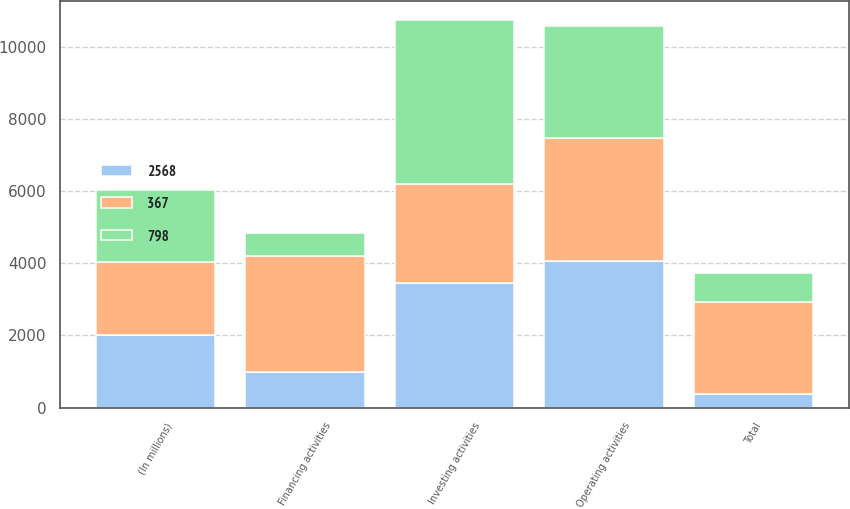Convert chart to OTSL. <chart><loc_0><loc_0><loc_500><loc_500><stacked_bar_chart><ecel><fcel>(In millions)<fcel>Operating activities<fcel>Investing activities<fcel>Financing activities<fcel>Total<nl><fcel>2568<fcel>2015<fcel>4061<fcel>3441<fcel>987<fcel>367<nl><fcel>798<fcel>2014<fcel>3110<fcel>4543<fcel>635<fcel>798<nl><fcel>367<fcel>2013<fcel>3405<fcel>2756<fcel>3217<fcel>2568<nl></chart> 